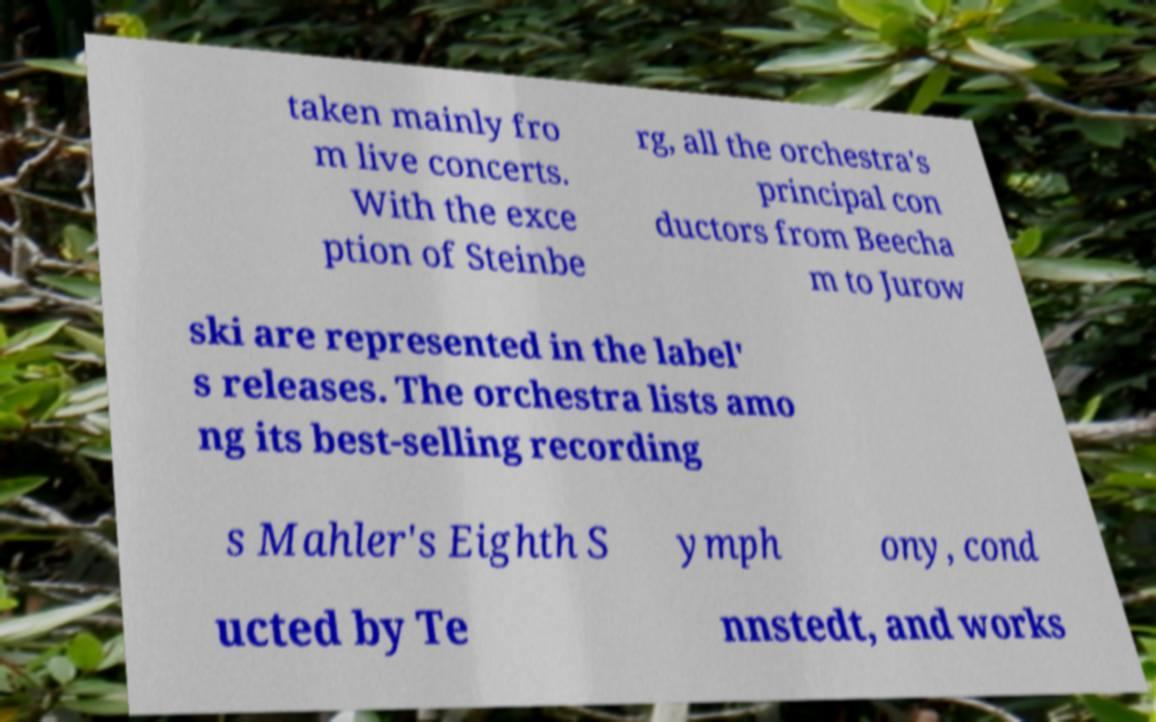Please read and relay the text visible in this image. What does it say? taken mainly fro m live concerts. With the exce ption of Steinbe rg, all the orchestra's principal con ductors from Beecha m to Jurow ski are represented in the label' s releases. The orchestra lists amo ng its best-selling recording s Mahler's Eighth S ymph ony, cond ucted by Te nnstedt, and works 